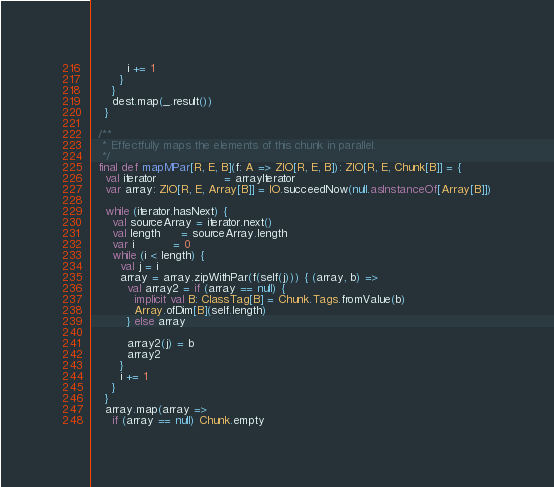Convert code to text. <code><loc_0><loc_0><loc_500><loc_500><_Scala_>          i += 1
        }
      }
      dest.map(_.result())
    }

  /**
   * Effectfully maps the elements of this chunk in parallel.
   */
  final def mapMPar[R, E, B](f: A => ZIO[R, E, B]): ZIO[R, E, Chunk[B]] = {
    val iterator                   = arrayIterator
    var array: ZIO[R, E, Array[B]] = IO.succeedNow(null.asInstanceOf[Array[B]])

    while (iterator.hasNext) {
      val sourceArray = iterator.next()
      val length      = sourceArray.length
      var i           = 0
      while (i < length) {
        val j = i
        array = array.zipWithPar(f(self(j))) { (array, b) =>
          val array2 = if (array == null) {
            implicit val B: ClassTag[B] = Chunk.Tags.fromValue(b)
            Array.ofDim[B](self.length)
          } else array

          array2(j) = b
          array2
        }
        i += 1
      }
    }
    array.map(array =>
      if (array == null) Chunk.empty</code> 